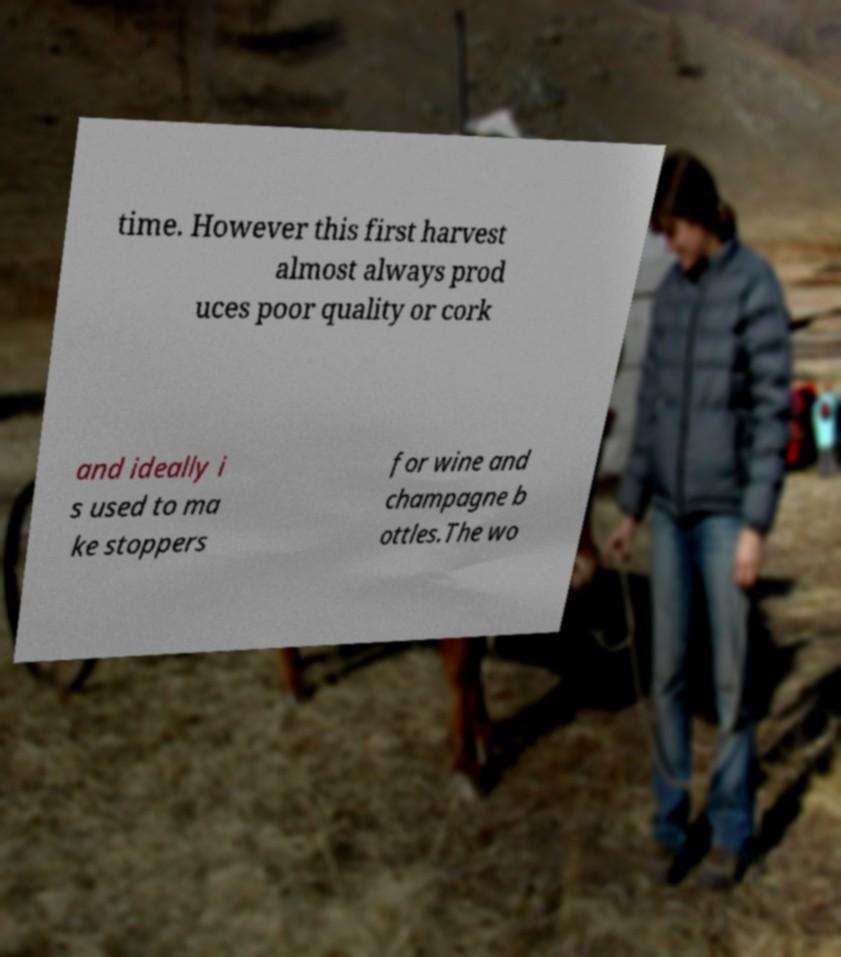What messages or text are displayed in this image? I need them in a readable, typed format. time. However this first harvest almost always prod uces poor quality or cork and ideally i s used to ma ke stoppers for wine and champagne b ottles.The wo 